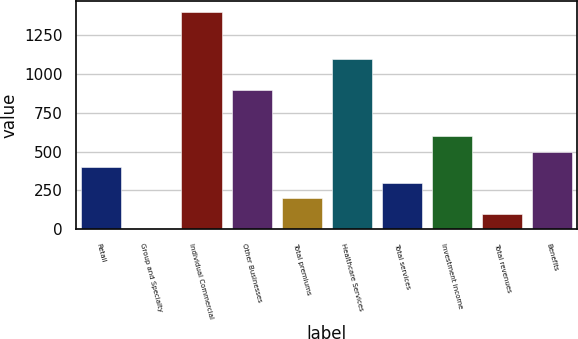Convert chart to OTSL. <chart><loc_0><loc_0><loc_500><loc_500><bar_chart><fcel>Retail<fcel>Group and Specialty<fcel>Individual Commercial<fcel>Other Businesses<fcel>Total premiums<fcel>Healthcare Services<fcel>Total services<fcel>Investment income<fcel>Total revenues<fcel>Benefits<nl><fcel>400.66<fcel>1.1<fcel>1399.56<fcel>900.11<fcel>200.88<fcel>1099.89<fcel>300.77<fcel>600.44<fcel>100.99<fcel>500.55<nl></chart> 